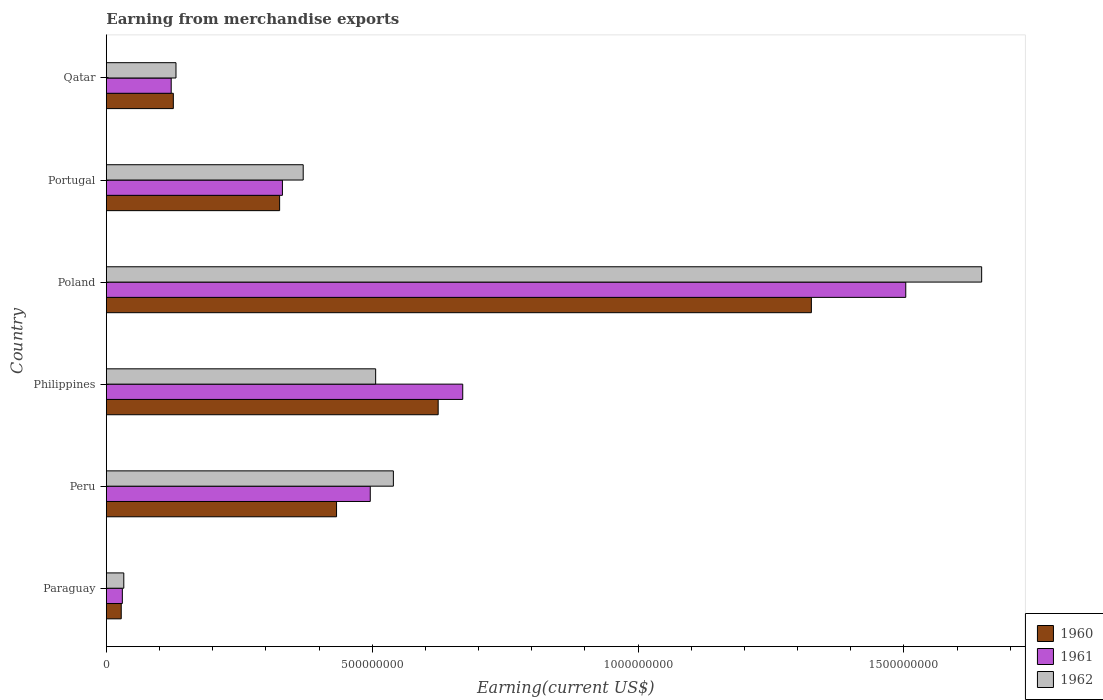How many different coloured bars are there?
Your answer should be compact. 3. Are the number of bars per tick equal to the number of legend labels?
Offer a terse response. Yes. How many bars are there on the 2nd tick from the bottom?
Keep it short and to the point. 3. What is the label of the 1st group of bars from the top?
Your answer should be very brief. Qatar. In how many cases, is the number of bars for a given country not equal to the number of legend labels?
Keep it short and to the point. 0. What is the amount earned from merchandise exports in 1962 in Paraguay?
Keep it short and to the point. 3.28e+07. Across all countries, what is the maximum amount earned from merchandise exports in 1960?
Give a very brief answer. 1.33e+09. Across all countries, what is the minimum amount earned from merchandise exports in 1961?
Your answer should be very brief. 3.01e+07. In which country was the amount earned from merchandise exports in 1960 minimum?
Offer a very short reply. Paraguay. What is the total amount earned from merchandise exports in 1962 in the graph?
Ensure brevity in your answer.  3.23e+09. What is the difference between the amount earned from merchandise exports in 1961 in Peru and that in Qatar?
Provide a succinct answer. 3.74e+08. What is the difference between the amount earned from merchandise exports in 1962 in Philippines and the amount earned from merchandise exports in 1960 in Paraguay?
Make the answer very short. 4.78e+08. What is the average amount earned from merchandise exports in 1962 per country?
Your answer should be very brief. 5.38e+08. What is the difference between the amount earned from merchandise exports in 1962 and amount earned from merchandise exports in 1960 in Qatar?
Ensure brevity in your answer.  5.00e+06. What is the ratio of the amount earned from merchandise exports in 1962 in Peru to that in Poland?
Offer a very short reply. 0.33. Is the difference between the amount earned from merchandise exports in 1962 in Peru and Portugal greater than the difference between the amount earned from merchandise exports in 1960 in Peru and Portugal?
Give a very brief answer. Yes. What is the difference between the highest and the second highest amount earned from merchandise exports in 1961?
Ensure brevity in your answer.  8.33e+08. What is the difference between the highest and the lowest amount earned from merchandise exports in 1960?
Give a very brief answer. 1.30e+09. In how many countries, is the amount earned from merchandise exports in 1961 greater than the average amount earned from merchandise exports in 1961 taken over all countries?
Make the answer very short. 2. What does the 1st bar from the top in Portugal represents?
Offer a terse response. 1962. How many bars are there?
Your answer should be compact. 18. Are all the bars in the graph horizontal?
Provide a succinct answer. Yes. How many countries are there in the graph?
Your answer should be compact. 6. How are the legend labels stacked?
Your answer should be compact. Vertical. What is the title of the graph?
Keep it short and to the point. Earning from merchandise exports. Does "1988" appear as one of the legend labels in the graph?
Provide a succinct answer. No. What is the label or title of the X-axis?
Provide a succinct answer. Earning(current US$). What is the label or title of the Y-axis?
Provide a succinct answer. Country. What is the Earning(current US$) of 1960 in Paraguay?
Offer a terse response. 2.80e+07. What is the Earning(current US$) in 1961 in Paraguay?
Provide a succinct answer. 3.01e+07. What is the Earning(current US$) in 1962 in Paraguay?
Your answer should be very brief. 3.28e+07. What is the Earning(current US$) in 1960 in Peru?
Provide a succinct answer. 4.33e+08. What is the Earning(current US$) of 1961 in Peru?
Your response must be concise. 4.96e+08. What is the Earning(current US$) of 1962 in Peru?
Your answer should be compact. 5.40e+08. What is the Earning(current US$) of 1960 in Philippines?
Make the answer very short. 6.24e+08. What is the Earning(current US$) in 1961 in Philippines?
Make the answer very short. 6.70e+08. What is the Earning(current US$) of 1962 in Philippines?
Your response must be concise. 5.07e+08. What is the Earning(current US$) in 1960 in Poland?
Make the answer very short. 1.33e+09. What is the Earning(current US$) in 1961 in Poland?
Your response must be concise. 1.50e+09. What is the Earning(current US$) in 1962 in Poland?
Offer a terse response. 1.65e+09. What is the Earning(current US$) in 1960 in Portugal?
Ensure brevity in your answer.  3.26e+08. What is the Earning(current US$) of 1961 in Portugal?
Provide a succinct answer. 3.31e+08. What is the Earning(current US$) in 1962 in Portugal?
Give a very brief answer. 3.70e+08. What is the Earning(current US$) in 1960 in Qatar?
Your answer should be compact. 1.26e+08. What is the Earning(current US$) of 1961 in Qatar?
Give a very brief answer. 1.22e+08. What is the Earning(current US$) of 1962 in Qatar?
Your response must be concise. 1.31e+08. Across all countries, what is the maximum Earning(current US$) in 1960?
Keep it short and to the point. 1.33e+09. Across all countries, what is the maximum Earning(current US$) of 1961?
Make the answer very short. 1.50e+09. Across all countries, what is the maximum Earning(current US$) in 1962?
Keep it short and to the point. 1.65e+09. Across all countries, what is the minimum Earning(current US$) in 1960?
Offer a very short reply. 2.80e+07. Across all countries, what is the minimum Earning(current US$) in 1961?
Offer a terse response. 3.01e+07. Across all countries, what is the minimum Earning(current US$) of 1962?
Make the answer very short. 3.28e+07. What is the total Earning(current US$) of 1960 in the graph?
Give a very brief answer. 2.86e+09. What is the total Earning(current US$) in 1961 in the graph?
Offer a terse response. 3.15e+09. What is the total Earning(current US$) in 1962 in the graph?
Offer a very short reply. 3.23e+09. What is the difference between the Earning(current US$) of 1960 in Paraguay and that in Peru?
Provide a short and direct response. -4.05e+08. What is the difference between the Earning(current US$) of 1961 in Paraguay and that in Peru?
Your response must be concise. -4.66e+08. What is the difference between the Earning(current US$) of 1962 in Paraguay and that in Peru?
Your response must be concise. -5.07e+08. What is the difference between the Earning(current US$) of 1960 in Paraguay and that in Philippines?
Your response must be concise. -5.96e+08. What is the difference between the Earning(current US$) of 1961 in Paraguay and that in Philippines?
Your response must be concise. -6.40e+08. What is the difference between the Earning(current US$) of 1962 in Paraguay and that in Philippines?
Offer a terse response. -4.74e+08. What is the difference between the Earning(current US$) in 1960 in Paraguay and that in Poland?
Provide a succinct answer. -1.30e+09. What is the difference between the Earning(current US$) in 1961 in Paraguay and that in Poland?
Provide a succinct answer. -1.47e+09. What is the difference between the Earning(current US$) of 1962 in Paraguay and that in Poland?
Offer a very short reply. -1.61e+09. What is the difference between the Earning(current US$) of 1960 in Paraguay and that in Portugal?
Your response must be concise. -2.98e+08. What is the difference between the Earning(current US$) of 1961 in Paraguay and that in Portugal?
Provide a succinct answer. -3.01e+08. What is the difference between the Earning(current US$) of 1962 in Paraguay and that in Portugal?
Your answer should be compact. -3.37e+08. What is the difference between the Earning(current US$) in 1960 in Paraguay and that in Qatar?
Provide a succinct answer. -9.80e+07. What is the difference between the Earning(current US$) in 1961 in Paraguay and that in Qatar?
Your response must be concise. -9.19e+07. What is the difference between the Earning(current US$) of 1962 in Paraguay and that in Qatar?
Provide a succinct answer. -9.82e+07. What is the difference between the Earning(current US$) in 1960 in Peru and that in Philippines?
Provide a succinct answer. -1.91e+08. What is the difference between the Earning(current US$) in 1961 in Peru and that in Philippines?
Provide a succinct answer. -1.74e+08. What is the difference between the Earning(current US$) of 1962 in Peru and that in Philippines?
Provide a succinct answer. 3.33e+07. What is the difference between the Earning(current US$) in 1960 in Peru and that in Poland?
Your answer should be compact. -8.93e+08. What is the difference between the Earning(current US$) in 1961 in Peru and that in Poland?
Ensure brevity in your answer.  -1.01e+09. What is the difference between the Earning(current US$) in 1962 in Peru and that in Poland?
Offer a terse response. -1.11e+09. What is the difference between the Earning(current US$) in 1960 in Peru and that in Portugal?
Offer a terse response. 1.07e+08. What is the difference between the Earning(current US$) of 1961 in Peru and that in Portugal?
Provide a short and direct response. 1.65e+08. What is the difference between the Earning(current US$) of 1962 in Peru and that in Portugal?
Your response must be concise. 1.70e+08. What is the difference between the Earning(current US$) of 1960 in Peru and that in Qatar?
Keep it short and to the point. 3.07e+08. What is the difference between the Earning(current US$) of 1961 in Peru and that in Qatar?
Provide a succinct answer. 3.74e+08. What is the difference between the Earning(current US$) of 1962 in Peru and that in Qatar?
Give a very brief answer. 4.09e+08. What is the difference between the Earning(current US$) in 1960 in Philippines and that in Poland?
Ensure brevity in your answer.  -7.02e+08. What is the difference between the Earning(current US$) of 1961 in Philippines and that in Poland?
Keep it short and to the point. -8.33e+08. What is the difference between the Earning(current US$) of 1962 in Philippines and that in Poland?
Provide a short and direct response. -1.14e+09. What is the difference between the Earning(current US$) of 1960 in Philippines and that in Portugal?
Keep it short and to the point. 2.98e+08. What is the difference between the Earning(current US$) in 1961 in Philippines and that in Portugal?
Your answer should be compact. 3.39e+08. What is the difference between the Earning(current US$) in 1962 in Philippines and that in Portugal?
Your answer should be very brief. 1.36e+08. What is the difference between the Earning(current US$) of 1960 in Philippines and that in Qatar?
Ensure brevity in your answer.  4.98e+08. What is the difference between the Earning(current US$) of 1961 in Philippines and that in Qatar?
Provide a succinct answer. 5.48e+08. What is the difference between the Earning(current US$) in 1962 in Philippines and that in Qatar?
Provide a succinct answer. 3.76e+08. What is the difference between the Earning(current US$) in 1960 in Poland and that in Portugal?
Your response must be concise. 1.00e+09. What is the difference between the Earning(current US$) of 1961 in Poland and that in Portugal?
Provide a short and direct response. 1.17e+09. What is the difference between the Earning(current US$) of 1962 in Poland and that in Portugal?
Keep it short and to the point. 1.28e+09. What is the difference between the Earning(current US$) of 1960 in Poland and that in Qatar?
Your response must be concise. 1.20e+09. What is the difference between the Earning(current US$) in 1961 in Poland and that in Qatar?
Offer a terse response. 1.38e+09. What is the difference between the Earning(current US$) of 1962 in Poland and that in Qatar?
Provide a short and direct response. 1.52e+09. What is the difference between the Earning(current US$) in 1960 in Portugal and that in Qatar?
Offer a very short reply. 2.00e+08. What is the difference between the Earning(current US$) in 1961 in Portugal and that in Qatar?
Your response must be concise. 2.09e+08. What is the difference between the Earning(current US$) of 1962 in Portugal and that in Qatar?
Provide a short and direct response. 2.39e+08. What is the difference between the Earning(current US$) in 1960 in Paraguay and the Earning(current US$) in 1961 in Peru?
Provide a succinct answer. -4.68e+08. What is the difference between the Earning(current US$) of 1960 in Paraguay and the Earning(current US$) of 1962 in Peru?
Ensure brevity in your answer.  -5.12e+08. What is the difference between the Earning(current US$) of 1961 in Paraguay and the Earning(current US$) of 1962 in Peru?
Provide a short and direct response. -5.10e+08. What is the difference between the Earning(current US$) of 1960 in Paraguay and the Earning(current US$) of 1961 in Philippines?
Offer a terse response. -6.42e+08. What is the difference between the Earning(current US$) in 1960 in Paraguay and the Earning(current US$) in 1962 in Philippines?
Offer a terse response. -4.78e+08. What is the difference between the Earning(current US$) in 1961 in Paraguay and the Earning(current US$) in 1962 in Philippines?
Keep it short and to the point. -4.76e+08. What is the difference between the Earning(current US$) of 1960 in Paraguay and the Earning(current US$) of 1961 in Poland?
Make the answer very short. -1.48e+09. What is the difference between the Earning(current US$) of 1960 in Paraguay and the Earning(current US$) of 1962 in Poland?
Provide a short and direct response. -1.62e+09. What is the difference between the Earning(current US$) in 1961 in Paraguay and the Earning(current US$) in 1962 in Poland?
Offer a very short reply. -1.62e+09. What is the difference between the Earning(current US$) in 1960 in Paraguay and the Earning(current US$) in 1961 in Portugal?
Your answer should be compact. -3.03e+08. What is the difference between the Earning(current US$) of 1960 in Paraguay and the Earning(current US$) of 1962 in Portugal?
Offer a very short reply. -3.42e+08. What is the difference between the Earning(current US$) of 1961 in Paraguay and the Earning(current US$) of 1962 in Portugal?
Provide a short and direct response. -3.40e+08. What is the difference between the Earning(current US$) in 1960 in Paraguay and the Earning(current US$) in 1961 in Qatar?
Your answer should be compact. -9.40e+07. What is the difference between the Earning(current US$) in 1960 in Paraguay and the Earning(current US$) in 1962 in Qatar?
Provide a succinct answer. -1.03e+08. What is the difference between the Earning(current US$) in 1961 in Paraguay and the Earning(current US$) in 1962 in Qatar?
Offer a very short reply. -1.01e+08. What is the difference between the Earning(current US$) of 1960 in Peru and the Earning(current US$) of 1961 in Philippines?
Your response must be concise. -2.37e+08. What is the difference between the Earning(current US$) of 1960 in Peru and the Earning(current US$) of 1962 in Philippines?
Ensure brevity in your answer.  -7.35e+07. What is the difference between the Earning(current US$) of 1961 in Peru and the Earning(current US$) of 1962 in Philippines?
Keep it short and to the point. -1.01e+07. What is the difference between the Earning(current US$) in 1960 in Peru and the Earning(current US$) in 1961 in Poland?
Give a very brief answer. -1.07e+09. What is the difference between the Earning(current US$) in 1960 in Peru and the Earning(current US$) in 1962 in Poland?
Ensure brevity in your answer.  -1.21e+09. What is the difference between the Earning(current US$) in 1961 in Peru and the Earning(current US$) in 1962 in Poland?
Your response must be concise. -1.15e+09. What is the difference between the Earning(current US$) of 1960 in Peru and the Earning(current US$) of 1961 in Portugal?
Ensure brevity in your answer.  1.02e+08. What is the difference between the Earning(current US$) of 1960 in Peru and the Earning(current US$) of 1962 in Portugal?
Your answer should be compact. 6.27e+07. What is the difference between the Earning(current US$) in 1961 in Peru and the Earning(current US$) in 1962 in Portugal?
Give a very brief answer. 1.26e+08. What is the difference between the Earning(current US$) in 1960 in Peru and the Earning(current US$) in 1961 in Qatar?
Offer a terse response. 3.11e+08. What is the difference between the Earning(current US$) of 1960 in Peru and the Earning(current US$) of 1962 in Qatar?
Keep it short and to the point. 3.02e+08. What is the difference between the Earning(current US$) in 1961 in Peru and the Earning(current US$) in 1962 in Qatar?
Offer a very short reply. 3.65e+08. What is the difference between the Earning(current US$) in 1960 in Philippines and the Earning(current US$) in 1961 in Poland?
Give a very brief answer. -8.79e+08. What is the difference between the Earning(current US$) in 1960 in Philippines and the Earning(current US$) in 1962 in Poland?
Offer a very short reply. -1.02e+09. What is the difference between the Earning(current US$) in 1961 in Philippines and the Earning(current US$) in 1962 in Poland?
Your response must be concise. -9.76e+08. What is the difference between the Earning(current US$) in 1960 in Philippines and the Earning(current US$) in 1961 in Portugal?
Offer a terse response. 2.93e+08. What is the difference between the Earning(current US$) in 1960 in Philippines and the Earning(current US$) in 1962 in Portugal?
Make the answer very short. 2.54e+08. What is the difference between the Earning(current US$) of 1961 in Philippines and the Earning(current US$) of 1962 in Portugal?
Your answer should be compact. 3.00e+08. What is the difference between the Earning(current US$) of 1960 in Philippines and the Earning(current US$) of 1961 in Qatar?
Ensure brevity in your answer.  5.02e+08. What is the difference between the Earning(current US$) of 1960 in Philippines and the Earning(current US$) of 1962 in Qatar?
Offer a terse response. 4.93e+08. What is the difference between the Earning(current US$) of 1961 in Philippines and the Earning(current US$) of 1962 in Qatar?
Your answer should be very brief. 5.39e+08. What is the difference between the Earning(current US$) in 1960 in Poland and the Earning(current US$) in 1961 in Portugal?
Provide a succinct answer. 9.95e+08. What is the difference between the Earning(current US$) in 1960 in Poland and the Earning(current US$) in 1962 in Portugal?
Offer a very short reply. 9.56e+08. What is the difference between the Earning(current US$) of 1961 in Poland and the Earning(current US$) of 1962 in Portugal?
Your response must be concise. 1.13e+09. What is the difference between the Earning(current US$) of 1960 in Poland and the Earning(current US$) of 1961 in Qatar?
Your answer should be compact. 1.20e+09. What is the difference between the Earning(current US$) of 1960 in Poland and the Earning(current US$) of 1962 in Qatar?
Ensure brevity in your answer.  1.20e+09. What is the difference between the Earning(current US$) of 1961 in Poland and the Earning(current US$) of 1962 in Qatar?
Offer a very short reply. 1.37e+09. What is the difference between the Earning(current US$) in 1960 in Portugal and the Earning(current US$) in 1961 in Qatar?
Provide a succinct answer. 2.04e+08. What is the difference between the Earning(current US$) of 1960 in Portugal and the Earning(current US$) of 1962 in Qatar?
Offer a terse response. 1.95e+08. What is the difference between the Earning(current US$) in 1961 in Portugal and the Earning(current US$) in 1962 in Qatar?
Offer a terse response. 2.00e+08. What is the average Earning(current US$) in 1960 per country?
Make the answer very short. 4.77e+08. What is the average Earning(current US$) in 1961 per country?
Provide a short and direct response. 5.26e+08. What is the average Earning(current US$) in 1962 per country?
Ensure brevity in your answer.  5.38e+08. What is the difference between the Earning(current US$) of 1960 and Earning(current US$) of 1961 in Paraguay?
Provide a succinct answer. -2.11e+06. What is the difference between the Earning(current US$) of 1960 and Earning(current US$) of 1962 in Paraguay?
Provide a succinct answer. -4.84e+06. What is the difference between the Earning(current US$) of 1961 and Earning(current US$) of 1962 in Paraguay?
Your answer should be compact. -2.73e+06. What is the difference between the Earning(current US$) in 1960 and Earning(current US$) in 1961 in Peru?
Keep it short and to the point. -6.34e+07. What is the difference between the Earning(current US$) of 1960 and Earning(current US$) of 1962 in Peru?
Your answer should be very brief. -1.07e+08. What is the difference between the Earning(current US$) in 1961 and Earning(current US$) in 1962 in Peru?
Offer a very short reply. -4.35e+07. What is the difference between the Earning(current US$) of 1960 and Earning(current US$) of 1961 in Philippines?
Give a very brief answer. -4.62e+07. What is the difference between the Earning(current US$) of 1960 and Earning(current US$) of 1962 in Philippines?
Offer a terse response. 1.18e+08. What is the difference between the Earning(current US$) in 1961 and Earning(current US$) in 1962 in Philippines?
Provide a short and direct response. 1.64e+08. What is the difference between the Earning(current US$) in 1960 and Earning(current US$) in 1961 in Poland?
Your answer should be very brief. -1.78e+08. What is the difference between the Earning(current US$) of 1960 and Earning(current US$) of 1962 in Poland?
Give a very brief answer. -3.20e+08. What is the difference between the Earning(current US$) of 1961 and Earning(current US$) of 1962 in Poland?
Offer a terse response. -1.43e+08. What is the difference between the Earning(current US$) in 1960 and Earning(current US$) in 1961 in Portugal?
Give a very brief answer. -5.25e+06. What is the difference between the Earning(current US$) of 1960 and Earning(current US$) of 1962 in Portugal?
Your answer should be very brief. -4.43e+07. What is the difference between the Earning(current US$) in 1961 and Earning(current US$) in 1962 in Portugal?
Your answer should be compact. -3.91e+07. What is the difference between the Earning(current US$) in 1960 and Earning(current US$) in 1961 in Qatar?
Make the answer very short. 4.00e+06. What is the difference between the Earning(current US$) of 1960 and Earning(current US$) of 1962 in Qatar?
Offer a terse response. -5.00e+06. What is the difference between the Earning(current US$) in 1961 and Earning(current US$) in 1962 in Qatar?
Offer a terse response. -9.00e+06. What is the ratio of the Earning(current US$) in 1960 in Paraguay to that in Peru?
Offer a terse response. 0.06. What is the ratio of the Earning(current US$) of 1961 in Paraguay to that in Peru?
Give a very brief answer. 0.06. What is the ratio of the Earning(current US$) of 1962 in Paraguay to that in Peru?
Offer a terse response. 0.06. What is the ratio of the Earning(current US$) of 1960 in Paraguay to that in Philippines?
Your answer should be compact. 0.04. What is the ratio of the Earning(current US$) of 1961 in Paraguay to that in Philippines?
Your answer should be compact. 0.04. What is the ratio of the Earning(current US$) of 1962 in Paraguay to that in Philippines?
Your answer should be very brief. 0.06. What is the ratio of the Earning(current US$) in 1960 in Paraguay to that in Poland?
Make the answer very short. 0.02. What is the ratio of the Earning(current US$) in 1960 in Paraguay to that in Portugal?
Keep it short and to the point. 0.09. What is the ratio of the Earning(current US$) of 1961 in Paraguay to that in Portugal?
Your response must be concise. 0.09. What is the ratio of the Earning(current US$) of 1962 in Paraguay to that in Portugal?
Offer a very short reply. 0.09. What is the ratio of the Earning(current US$) in 1960 in Paraguay to that in Qatar?
Your response must be concise. 0.22. What is the ratio of the Earning(current US$) in 1961 in Paraguay to that in Qatar?
Give a very brief answer. 0.25. What is the ratio of the Earning(current US$) in 1962 in Paraguay to that in Qatar?
Ensure brevity in your answer.  0.25. What is the ratio of the Earning(current US$) in 1960 in Peru to that in Philippines?
Provide a succinct answer. 0.69. What is the ratio of the Earning(current US$) of 1961 in Peru to that in Philippines?
Give a very brief answer. 0.74. What is the ratio of the Earning(current US$) in 1962 in Peru to that in Philippines?
Your answer should be compact. 1.07. What is the ratio of the Earning(current US$) of 1960 in Peru to that in Poland?
Offer a very short reply. 0.33. What is the ratio of the Earning(current US$) in 1961 in Peru to that in Poland?
Offer a very short reply. 0.33. What is the ratio of the Earning(current US$) in 1962 in Peru to that in Poland?
Make the answer very short. 0.33. What is the ratio of the Earning(current US$) of 1960 in Peru to that in Portugal?
Ensure brevity in your answer.  1.33. What is the ratio of the Earning(current US$) of 1961 in Peru to that in Portugal?
Your answer should be very brief. 1.5. What is the ratio of the Earning(current US$) in 1962 in Peru to that in Portugal?
Make the answer very short. 1.46. What is the ratio of the Earning(current US$) of 1960 in Peru to that in Qatar?
Keep it short and to the point. 3.44. What is the ratio of the Earning(current US$) in 1961 in Peru to that in Qatar?
Keep it short and to the point. 4.07. What is the ratio of the Earning(current US$) of 1962 in Peru to that in Qatar?
Your response must be concise. 4.12. What is the ratio of the Earning(current US$) of 1960 in Philippines to that in Poland?
Your answer should be very brief. 0.47. What is the ratio of the Earning(current US$) in 1961 in Philippines to that in Poland?
Your answer should be very brief. 0.45. What is the ratio of the Earning(current US$) of 1962 in Philippines to that in Poland?
Offer a very short reply. 0.31. What is the ratio of the Earning(current US$) of 1960 in Philippines to that in Portugal?
Your response must be concise. 1.91. What is the ratio of the Earning(current US$) of 1961 in Philippines to that in Portugal?
Your response must be concise. 2.02. What is the ratio of the Earning(current US$) in 1962 in Philippines to that in Portugal?
Your answer should be compact. 1.37. What is the ratio of the Earning(current US$) of 1960 in Philippines to that in Qatar?
Offer a terse response. 4.95. What is the ratio of the Earning(current US$) of 1961 in Philippines to that in Qatar?
Ensure brevity in your answer.  5.49. What is the ratio of the Earning(current US$) of 1962 in Philippines to that in Qatar?
Ensure brevity in your answer.  3.87. What is the ratio of the Earning(current US$) in 1960 in Poland to that in Portugal?
Offer a terse response. 4.07. What is the ratio of the Earning(current US$) of 1961 in Poland to that in Portugal?
Your response must be concise. 4.54. What is the ratio of the Earning(current US$) of 1962 in Poland to that in Portugal?
Your answer should be compact. 4.45. What is the ratio of the Earning(current US$) in 1960 in Poland to that in Qatar?
Make the answer very short. 10.52. What is the ratio of the Earning(current US$) of 1961 in Poland to that in Qatar?
Provide a succinct answer. 12.32. What is the ratio of the Earning(current US$) in 1962 in Poland to that in Qatar?
Your response must be concise. 12.57. What is the ratio of the Earning(current US$) of 1960 in Portugal to that in Qatar?
Give a very brief answer. 2.59. What is the ratio of the Earning(current US$) in 1961 in Portugal to that in Qatar?
Keep it short and to the point. 2.71. What is the ratio of the Earning(current US$) of 1962 in Portugal to that in Qatar?
Your response must be concise. 2.83. What is the difference between the highest and the second highest Earning(current US$) in 1960?
Your answer should be compact. 7.02e+08. What is the difference between the highest and the second highest Earning(current US$) in 1961?
Your answer should be compact. 8.33e+08. What is the difference between the highest and the second highest Earning(current US$) in 1962?
Offer a terse response. 1.11e+09. What is the difference between the highest and the lowest Earning(current US$) in 1960?
Make the answer very short. 1.30e+09. What is the difference between the highest and the lowest Earning(current US$) of 1961?
Offer a terse response. 1.47e+09. What is the difference between the highest and the lowest Earning(current US$) of 1962?
Provide a short and direct response. 1.61e+09. 